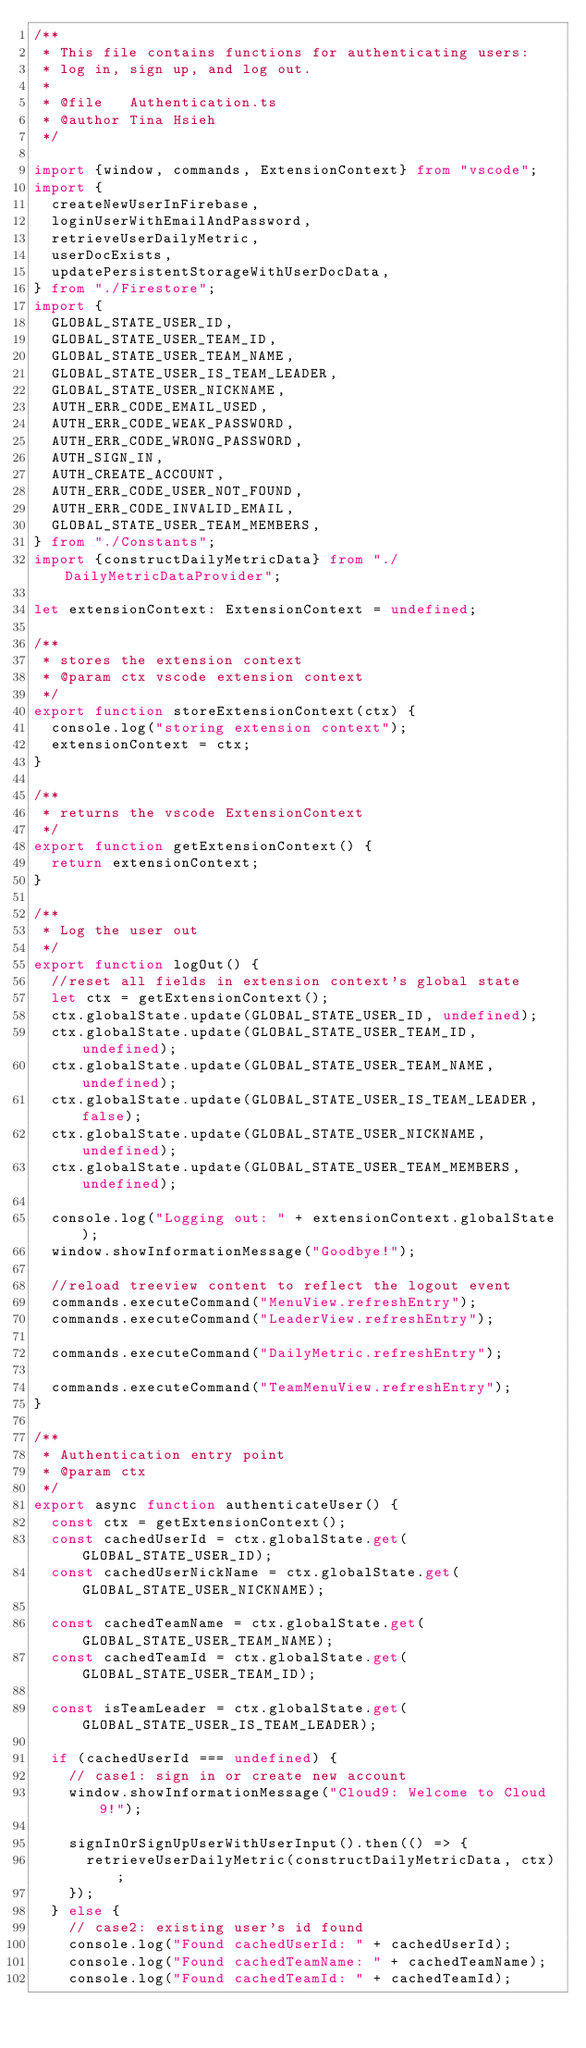Convert code to text. <code><loc_0><loc_0><loc_500><loc_500><_TypeScript_>/**
 * This file contains functions for authenticating users:
 * log in, sign up, and log out.
 *
 * @file   Authentication.ts
 * @author Tina Hsieh
 */

import {window, commands, ExtensionContext} from "vscode";
import {
  createNewUserInFirebase,
  loginUserWithEmailAndPassword,
  retrieveUserDailyMetric,
  userDocExists,
  updatePersistentStorageWithUserDocData,
} from "./Firestore";
import {
  GLOBAL_STATE_USER_ID,
  GLOBAL_STATE_USER_TEAM_ID,
  GLOBAL_STATE_USER_TEAM_NAME,
  GLOBAL_STATE_USER_IS_TEAM_LEADER,
  GLOBAL_STATE_USER_NICKNAME,
  AUTH_ERR_CODE_EMAIL_USED,
  AUTH_ERR_CODE_WEAK_PASSWORD,
  AUTH_ERR_CODE_WRONG_PASSWORD,
  AUTH_SIGN_IN,
  AUTH_CREATE_ACCOUNT,
  AUTH_ERR_CODE_USER_NOT_FOUND,
  AUTH_ERR_CODE_INVALID_EMAIL,
  GLOBAL_STATE_USER_TEAM_MEMBERS,
} from "./Constants";
import {constructDailyMetricData} from "./DailyMetricDataProvider";

let extensionContext: ExtensionContext = undefined;

/**
 * stores the extension context
 * @param ctx vscode extension context
 */
export function storeExtensionContext(ctx) {
  console.log("storing extension context");
  extensionContext = ctx;
}

/**
 * returns the vscode ExtensionContext
 */
export function getExtensionContext() {
  return extensionContext;
}

/**
 * Log the user out
 */
export function logOut() {
  //reset all fields in extension context's global state
  let ctx = getExtensionContext();
  ctx.globalState.update(GLOBAL_STATE_USER_ID, undefined);
  ctx.globalState.update(GLOBAL_STATE_USER_TEAM_ID, undefined);
  ctx.globalState.update(GLOBAL_STATE_USER_TEAM_NAME, undefined);
  ctx.globalState.update(GLOBAL_STATE_USER_IS_TEAM_LEADER, false);
  ctx.globalState.update(GLOBAL_STATE_USER_NICKNAME, undefined);
  ctx.globalState.update(GLOBAL_STATE_USER_TEAM_MEMBERS, undefined);

  console.log("Logging out: " + extensionContext.globalState);
  window.showInformationMessage("Goodbye!");

  //reload treeview content to reflect the logout event
  commands.executeCommand("MenuView.refreshEntry");
  commands.executeCommand("LeaderView.refreshEntry");

  commands.executeCommand("DailyMetric.refreshEntry");

  commands.executeCommand("TeamMenuView.refreshEntry");
}

/**
 * Authentication entry point
 * @param ctx
 */
export async function authenticateUser() {
  const ctx = getExtensionContext();
  const cachedUserId = ctx.globalState.get(GLOBAL_STATE_USER_ID);
  const cachedUserNickName = ctx.globalState.get(GLOBAL_STATE_USER_NICKNAME);

  const cachedTeamName = ctx.globalState.get(GLOBAL_STATE_USER_TEAM_NAME);
  const cachedTeamId = ctx.globalState.get(GLOBAL_STATE_USER_TEAM_ID);

  const isTeamLeader = ctx.globalState.get(GLOBAL_STATE_USER_IS_TEAM_LEADER);

  if (cachedUserId === undefined) {
    // case1: sign in or create new account
    window.showInformationMessage("Cloud9: Welcome to Cloud 9!");

    signInOrSignUpUserWithUserInput().then(() => {
      retrieveUserDailyMetric(constructDailyMetricData, ctx);
    });
  } else {
    // case2: existing user's id found
    console.log("Found cachedUserId: " + cachedUserId);
    console.log("Found cachedTeamName: " + cachedTeamName);
    console.log("Found cachedTeamId: " + cachedTeamId);</code> 